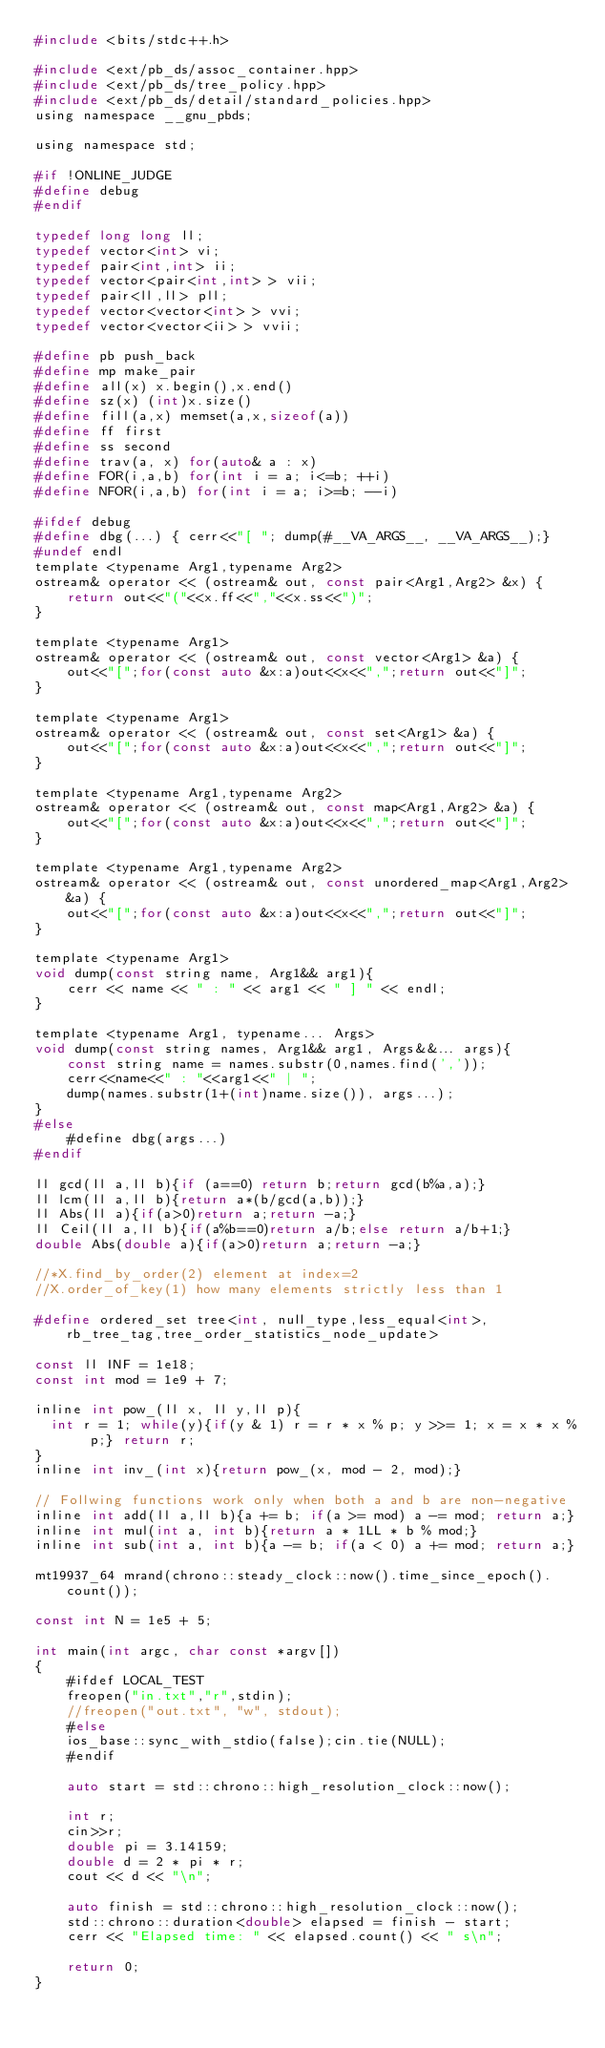<code> <loc_0><loc_0><loc_500><loc_500><_C_>#include <bits/stdc++.h>
  
#include <ext/pb_ds/assoc_container.hpp>
#include <ext/pb_ds/tree_policy.hpp>
#include <ext/pb_ds/detail/standard_policies.hpp>
using namespace __gnu_pbds;
 
using namespace std;
 
#if !ONLINE_JUDGE
#define debug
#endif
 
typedef long long ll;
typedef vector<int> vi;
typedef pair<int,int> ii;
typedef vector<pair<int,int> > vii;
typedef pair<ll,ll> pll;
typedef vector<vector<int> > vvi;
typedef vector<vector<ii> > vvii;
 
#define pb push_back
#define mp make_pair
#define all(x) x.begin(),x.end()
#define sz(x) (int)x.size()
#define fill(a,x) memset(a,x,sizeof(a))
#define ff first
#define ss second
#define trav(a, x) for(auto& a : x) 
#define FOR(i,a,b) for(int i = a; i<=b; ++i)
#define NFOR(i,a,b) for(int i = a; i>=b; --i)

#ifdef debug
#define dbg(...) { cerr<<"[ "; dump(#__VA_ARGS__, __VA_ARGS__);}
#undef endl
template <typename Arg1,typename Arg2>
ostream& operator << (ostream& out, const pair<Arg1,Arg2> &x) {
    return out<<"("<<x.ff<<","<<x.ss<<")";
}
 
template <typename Arg1>
ostream& operator << (ostream& out, const vector<Arg1> &a) {
    out<<"[";for(const auto &x:a)out<<x<<",";return out<<"]";
}
 
template <typename Arg1>
ostream& operator << (ostream& out, const set<Arg1> &a) {
    out<<"[";for(const auto &x:a)out<<x<<",";return out<<"]";
}
 
template <typename Arg1,typename Arg2>
ostream& operator << (ostream& out, const map<Arg1,Arg2> &a) {
    out<<"[";for(const auto &x:a)out<<x<<",";return out<<"]";
}
 
template <typename Arg1,typename Arg2>
ostream& operator << (ostream& out, const unordered_map<Arg1,Arg2> &a) {
    out<<"[";for(const auto &x:a)out<<x<<",";return out<<"]";
} 
 
template <typename Arg1>
void dump(const string name, Arg1&& arg1){
    cerr << name << " : " << arg1 << " ] " << endl;
}
 
template <typename Arg1, typename... Args>
void dump(const string names, Arg1&& arg1, Args&&... args){
    const string name = names.substr(0,names.find(','));
    cerr<<name<<" : "<<arg1<<" | ";
    dump(names.substr(1+(int)name.size()), args...);
}
#else
    #define dbg(args...)
#endif
 
ll gcd(ll a,ll b){if (a==0) return b;return gcd(b%a,a);}
ll lcm(ll a,ll b){return a*(b/gcd(a,b));}
ll Abs(ll a){if(a>0)return a;return -a;}
ll Ceil(ll a,ll b){if(a%b==0)return a/b;else return a/b+1;}
double Abs(double a){if(a>0)return a;return -a;}
 
//*X.find_by_order(2) element at index=2
//X.order_of_key(1) how many elements strictly less than 1
 
#define ordered_set tree<int, null_type,less_equal<int>, rb_tree_tag,tree_order_statistics_node_update> 

const ll INF = 1e18;
const int mod = 1e9 + 7;
 
inline int pow_(ll x, ll y,ll p){
  int r = 1; while(y){if(y & 1) r = r * x % p; y >>= 1; x = x * x % p;} return r;
}
inline int inv_(int x){return pow_(x, mod - 2, mod);}

// Follwing functions work only when both a and b are non-negative
inline int add(ll a,ll b){a += b; if(a >= mod) a -= mod; return a;}
inline int mul(int a, int b){return a * 1LL * b % mod;}
inline int sub(int a, int b){a -= b; if(a < 0) a += mod; return a;}
  
mt19937_64 mrand(chrono::steady_clock::now().time_since_epoch().count());
 
const int N = 1e5 + 5;
 
int main(int argc, char const *argv[])
{
    #ifdef LOCAL_TEST
    freopen("in.txt","r",stdin);
    //freopen("out.txt", "w", stdout);
    #else
    ios_base::sync_with_stdio(false);cin.tie(NULL);
    #endif

    auto start = std::chrono::high_resolution_clock::now();

    int r;
    cin>>r;
    double pi = 3.14159;
    double d = 2 * pi * r;
    cout << d << "\n";

    auto finish = std::chrono::high_resolution_clock::now();  
    std::chrono::duration<double> elapsed = finish - start;
    cerr << "Elapsed time: " << elapsed.count() << " s\n";
    
    return 0;    
}</code> 